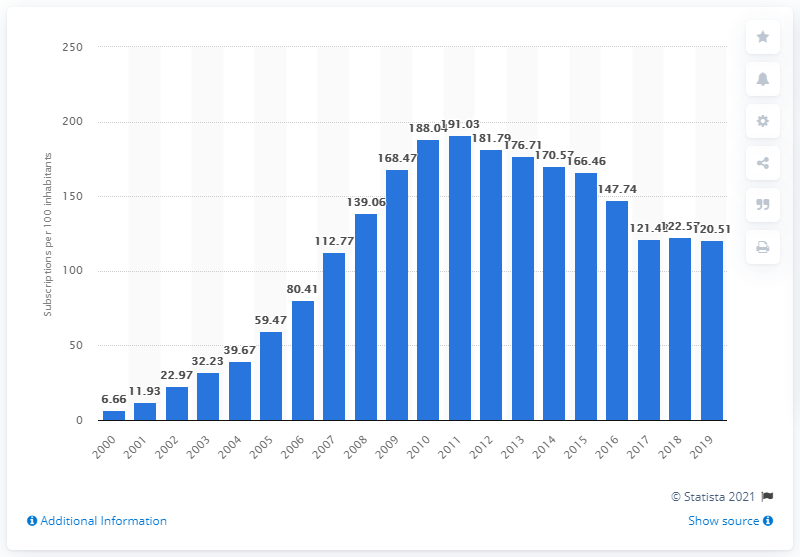Point out several critical features in this image. The number of mobile subscriptions per 100 people in Saudi Arabia fluctuated between 2000 and 2019, with an average of 120.51 subscriptions per 100 people over the period. 